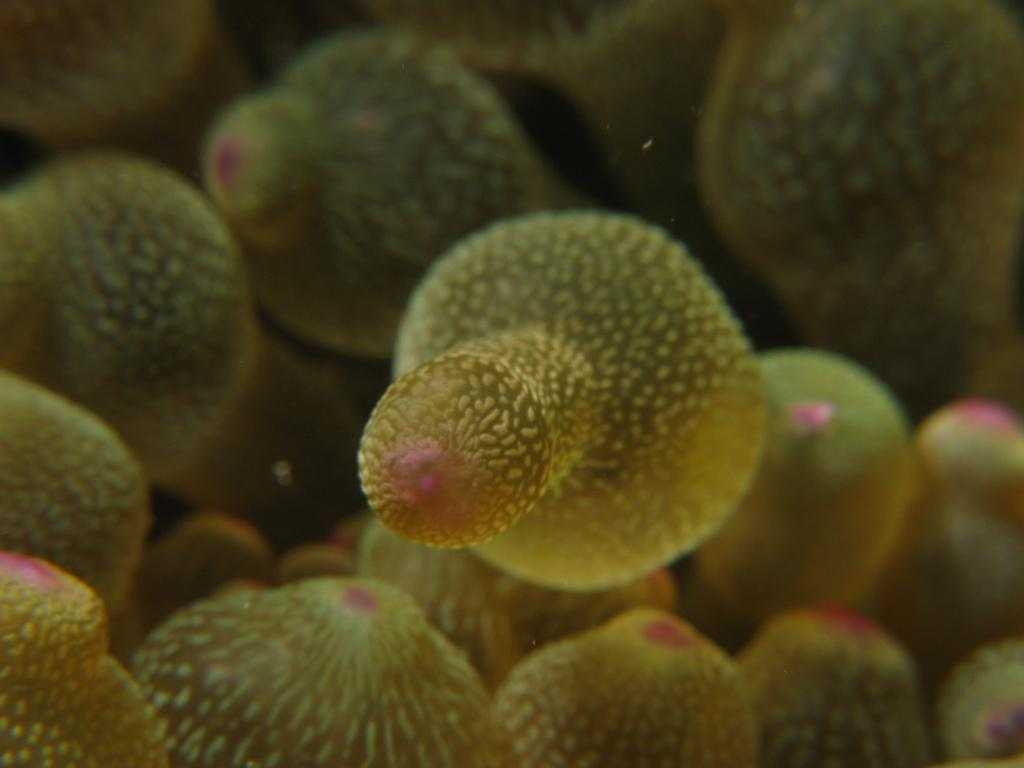What type of natural formation can be seen in the image? There are green color corals visible in the image. Can you describe the color of the corals? The corals are green in color. How does the pin compare to the corals in the image? There is no pin present in the image, so it cannot be compared to the corals. 